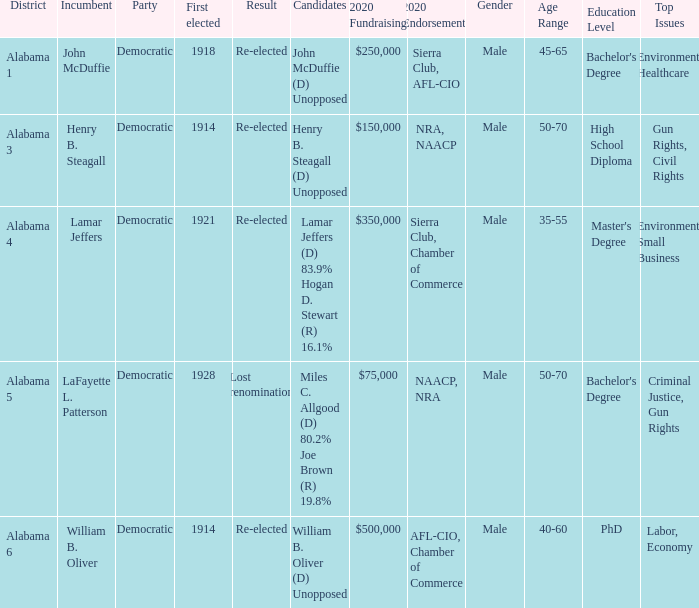Would you be able to parse every entry in this table? {'header': ['District', 'Incumbent', 'Party', 'First elected', 'Result', 'Candidates', '2020 Fundraising', '2020 Endorsements', 'Gender', 'Age Range', 'Education Level', 'Top Issues'], 'rows': [['Alabama 1', 'John McDuffie', 'Democratic', '1918', 'Re-elected', 'John McDuffie (D) Unopposed', '$250,000', 'Sierra Club, AFL-CIO', 'Male', '45-65', "Bachelor's Degree", 'Environment, Healthcare'], ['Alabama 3', 'Henry B. Steagall', 'Democratic', '1914', 'Re-elected', 'Henry B. Steagall (D) Unopposed', '$150,000', 'NRA, NAACP', 'Male', '50-70', 'High School Diploma', 'Gun Rights, Civil Rights'], ['Alabama 4', 'Lamar Jeffers', 'Democratic', '1921', 'Re-elected', 'Lamar Jeffers (D) 83.9% Hogan D. Stewart (R) 16.1%', '$350,000', 'Sierra Club, Chamber of Commerce', 'Male', '35-55', "Master's Degree", 'Environment, Small Business'], ['Alabama 5', 'LaFayette L. Patterson', 'Democratic', '1928', 'Lost renomination', 'Miles C. Allgood (D) 80.2% Joe Brown (R) 19.8%', '$75,000', 'NAACP, NRA', 'Male', '50-70', "Bachelor's Degree", 'Criminal Justice, Gun Rights'], ['Alabama 6', 'William B. Oliver', 'Democratic', '1914', 'Re-elected', 'William B. Oliver (D) Unopposed', '$500,000', 'AFL-CIO, Chamber of Commerce', 'Male', '40-60', 'PhD', 'Labor, Economy']]} What kind of party is the district in Alabama 1? Democratic. 